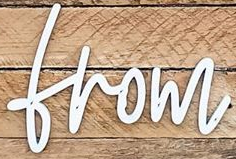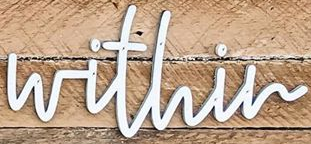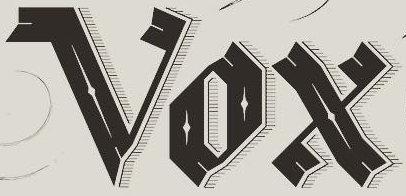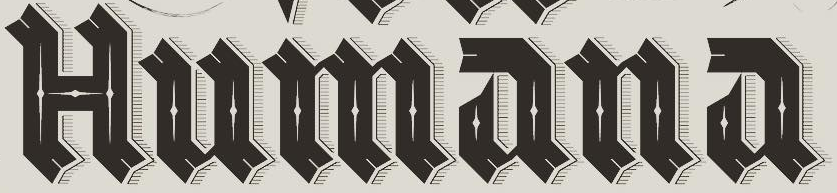What text is displayed in these images sequentially, separated by a semicolon? from; within; Vox; Humana 